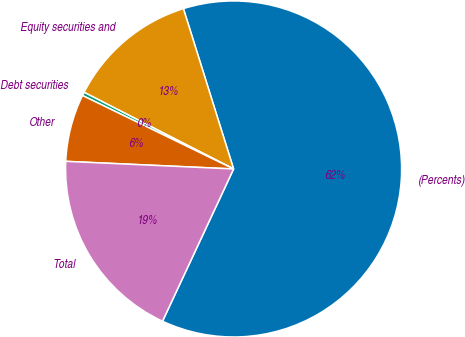Convert chart. <chart><loc_0><loc_0><loc_500><loc_500><pie_chart><fcel>(Percents)<fcel>Equity securities and<fcel>Debt securities<fcel>Other<fcel>Total<nl><fcel>61.78%<fcel>12.63%<fcel>0.34%<fcel>6.48%<fcel>18.77%<nl></chart> 